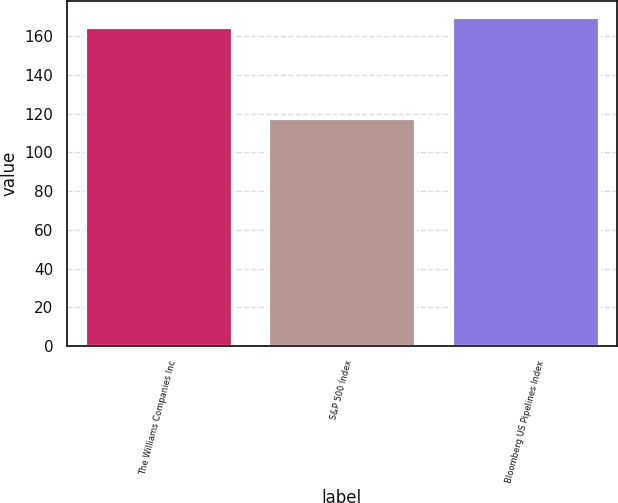Convert chart to OTSL. <chart><loc_0><loc_0><loc_500><loc_500><bar_chart><fcel>The Williams Companies Inc<fcel>S&P 500 Index<fcel>Bloomberg US Pipelines Index<nl><fcel>164.5<fcel>117.5<fcel>169.71<nl></chart> 